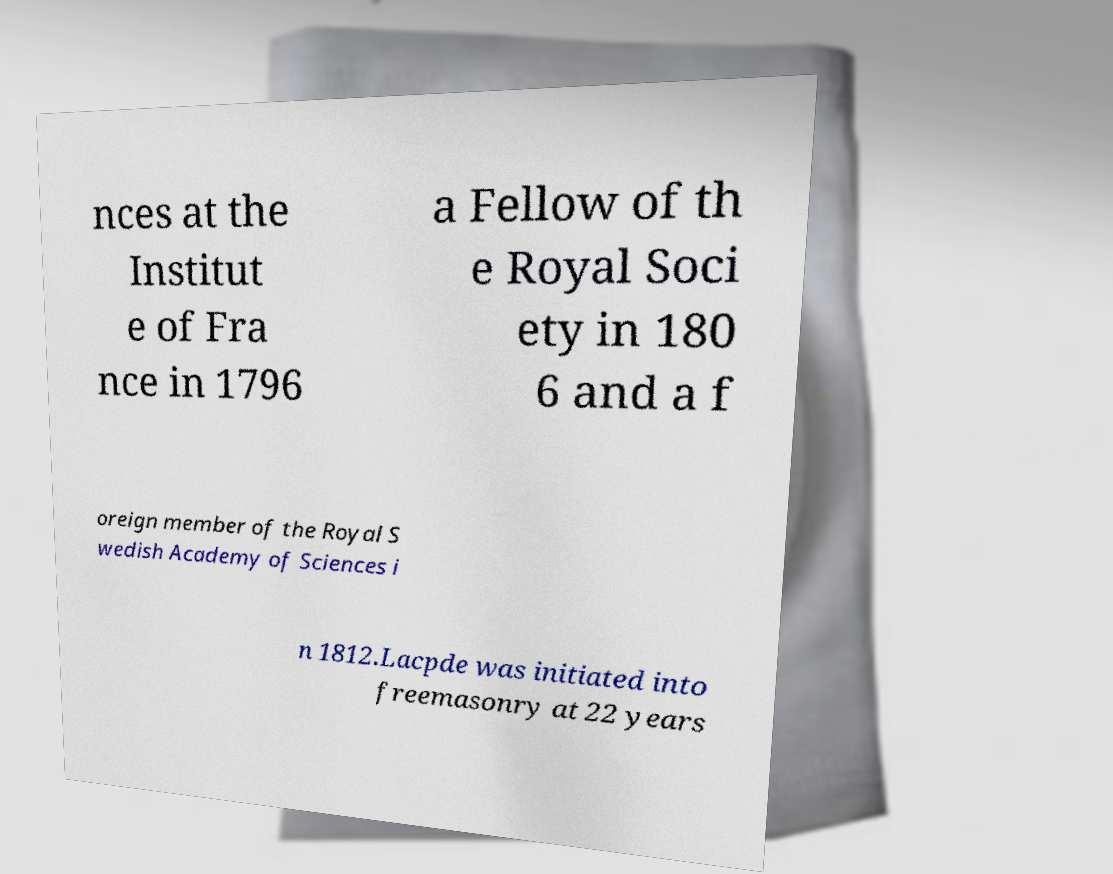Please read and relay the text visible in this image. What does it say? nces at the Institut e of Fra nce in 1796 a Fellow of th e Royal Soci ety in 180 6 and a f oreign member of the Royal S wedish Academy of Sciences i n 1812.Lacpde was initiated into freemasonry at 22 years 